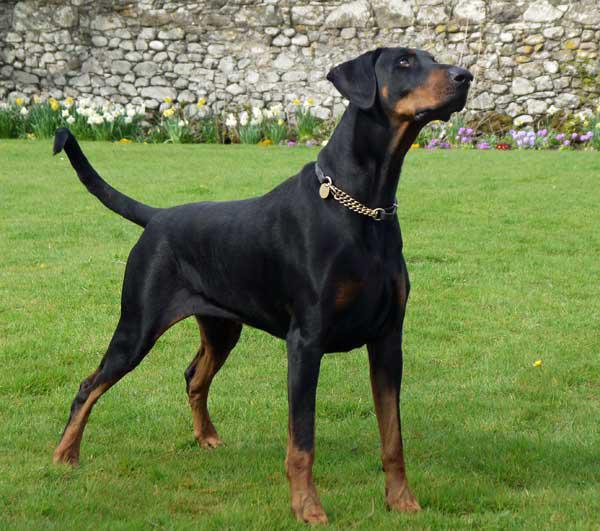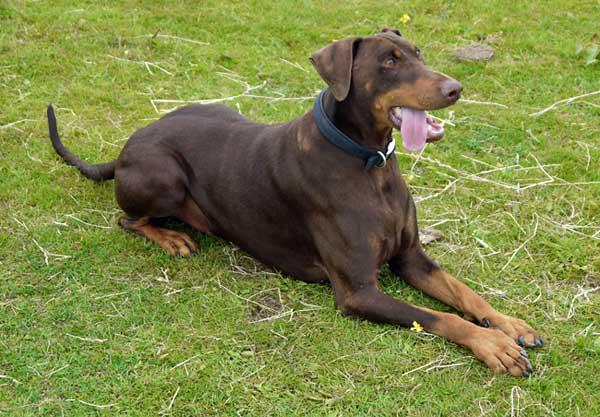The first image is the image on the left, the second image is the image on the right. Considering the images on both sides, is "There are dogs standing in each image" valid? Answer yes or no. No. The first image is the image on the left, the second image is the image on the right. Considering the images on both sides, is "The dog in the image on the left has its mouth closed." valid? Answer yes or no. Yes. 